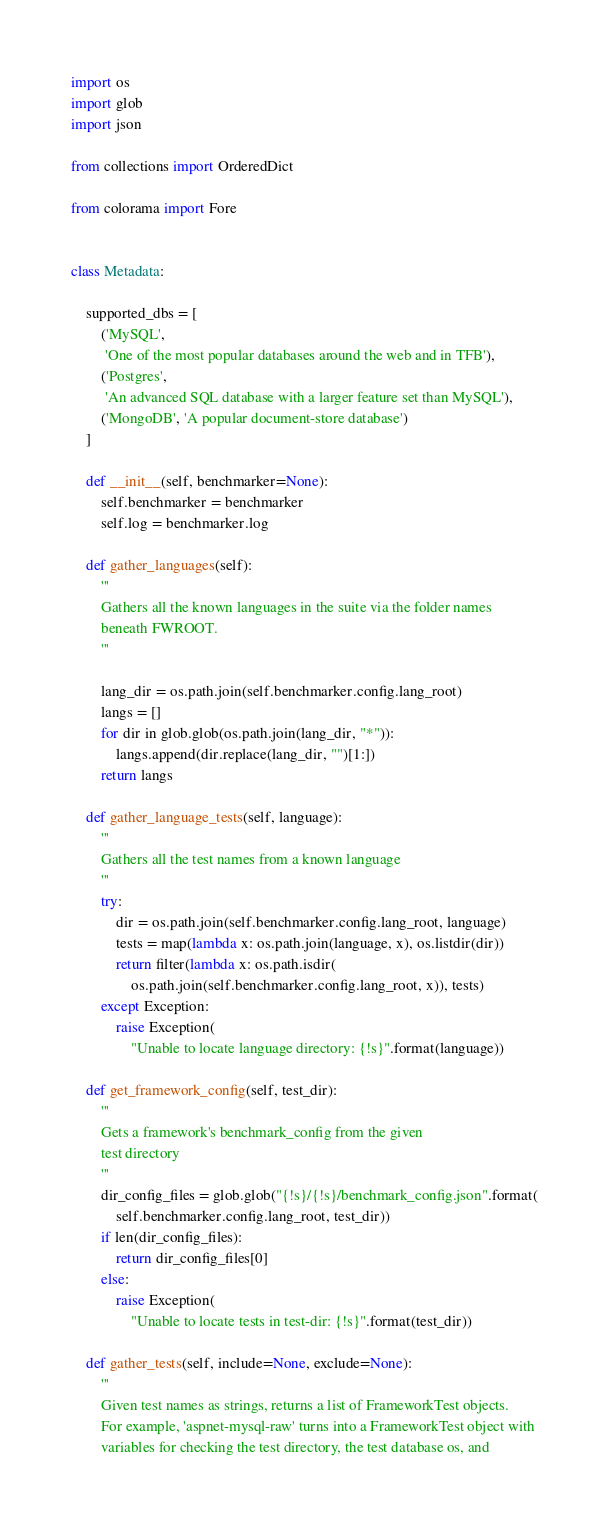Convert code to text. <code><loc_0><loc_0><loc_500><loc_500><_Python_>import os
import glob
import json

from collections import OrderedDict

from colorama import Fore


class Metadata:

    supported_dbs = [
        ('MySQL',
         'One of the most popular databases around the web and in TFB'),
        ('Postgres',
         'An advanced SQL database with a larger feature set than MySQL'),
        ('MongoDB', 'A popular document-store database')
    ]

    def __init__(self, benchmarker=None):
        self.benchmarker = benchmarker
        self.log = benchmarker.log

    def gather_languages(self):
        '''
        Gathers all the known languages in the suite via the folder names
        beneath FWROOT.
        '''

        lang_dir = os.path.join(self.benchmarker.config.lang_root)
        langs = []
        for dir in glob.glob(os.path.join(lang_dir, "*")):
            langs.append(dir.replace(lang_dir, "")[1:])
        return langs

    def gather_language_tests(self, language):
        '''
        Gathers all the test names from a known language
        '''
        try:
            dir = os.path.join(self.benchmarker.config.lang_root, language)
            tests = map(lambda x: os.path.join(language, x), os.listdir(dir))
            return filter(lambda x: os.path.isdir(
                os.path.join(self.benchmarker.config.lang_root, x)), tests)
        except Exception:
            raise Exception(
                "Unable to locate language directory: {!s}".format(language))

    def get_framework_config(self, test_dir):
        '''
        Gets a framework's benchmark_config from the given
        test directory
        '''
        dir_config_files = glob.glob("{!s}/{!s}/benchmark_config.json".format(
            self.benchmarker.config.lang_root, test_dir))
        if len(dir_config_files):
            return dir_config_files[0]
        else:
            raise Exception(
                "Unable to locate tests in test-dir: {!s}".format(test_dir))

    def gather_tests(self, include=None, exclude=None):
        '''
        Given test names as strings, returns a list of FrameworkTest objects.
        For example, 'aspnet-mysql-raw' turns into a FrameworkTest object with
        variables for checking the test directory, the test database os, and</code> 